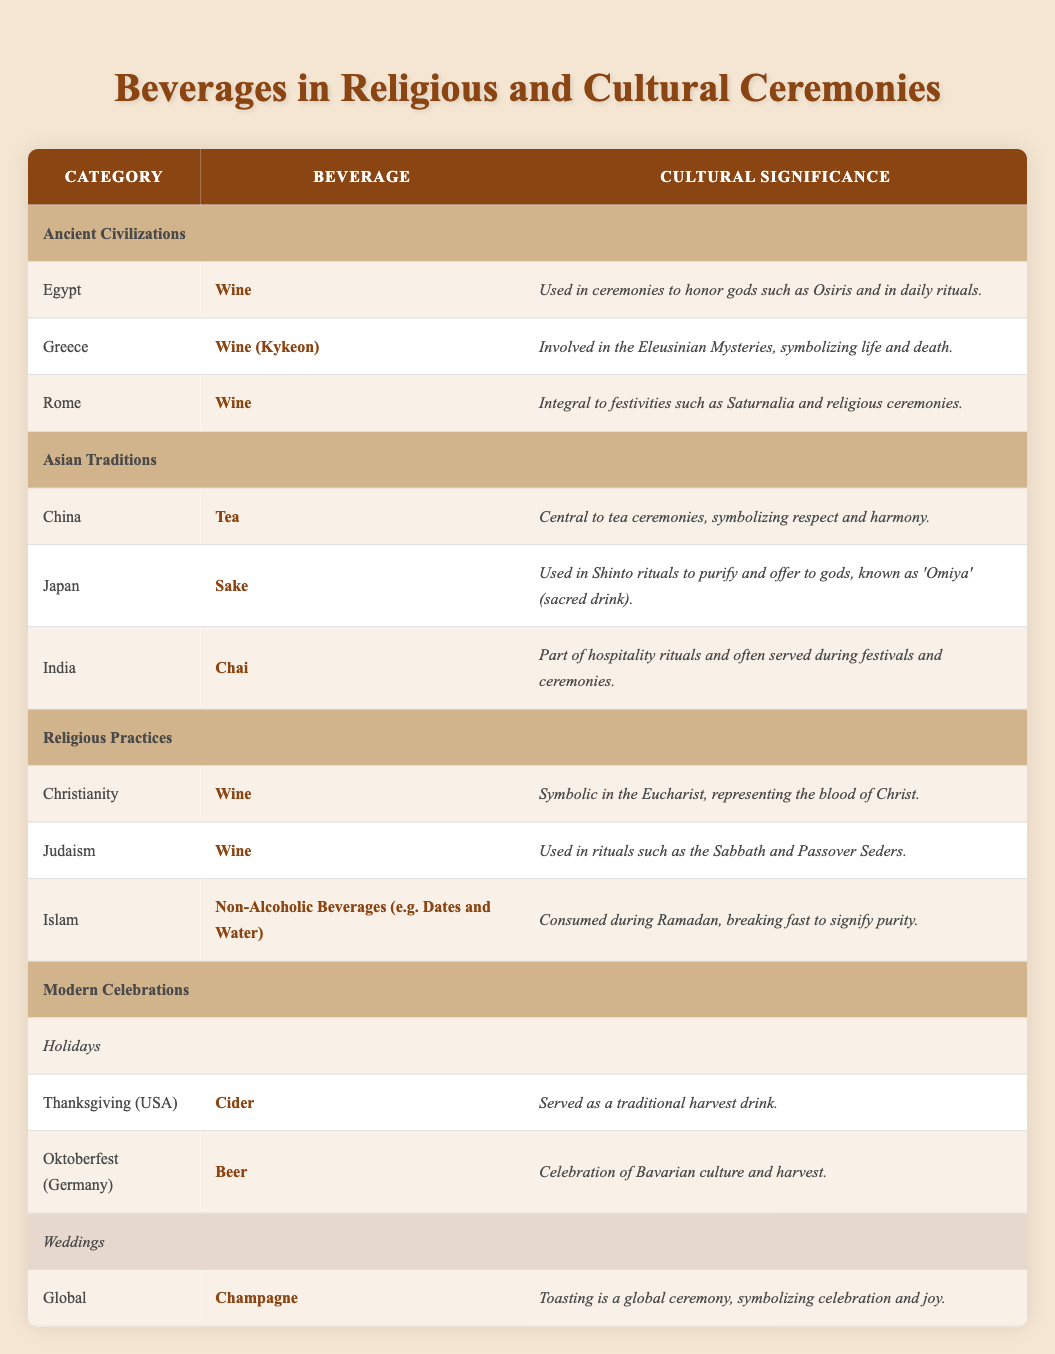What beverage was used in Ancient Egyptian ceremonies? According to the table, the beverage used in Ancient Egyptian ceremonies is wine. This can be found in the 'Ancient Civilizations' section under 'Egypt'.
Answer: Wine Which beverage is central to tea ceremonies in China? The table indicates that tea is the beverage that is central to tea ceremonies in China. This is specifically listed under the 'Asian Traditions' section.
Answer: Tea True or False: Sake is used in Shinto rituals in Japan. The table confirms that sake is used in Shinto rituals as part of its cultural significance, making this statement true. This information is found in the 'Asian Traditions' section under 'Japan'.
Answer: True What are the cultural significances associated with wine in Christianity and Judaism? The cultural significance of wine in Christianity, as listed, is that it is symbolic in the Eucharist, representing the blood of Christ. In Judaism, wine is used in rituals such as the Sabbath and Passover Seders. Both of these details can be found in the 'Religious Practices' section.
Answer: Symbolic in Eucharist (Christianity), used in rituals (Judaism) How many different beverages associated with modern celebrations are listed in the table? The table shows that there are three distinct beverages associated with modern celebrations: cider for Thanksgiving, beer for Oktoberfest, and champagne for weddings. Counting these entries confirms that there are three beverages total.
Answer: 3 What beverage represents a traditional harvest drink in the USA? The table states that cider is served as a traditional harvest drink during Thanksgiving in the USA. This is categorized under the 'Modern Celebrations' section in the 'Holidays' category.
Answer: Cider Which beverage is associated with the celebration of Bavarian culture? According to the table, beer is the beverage associated with the celebration of Bavarian culture during Oktoberfest, which is noted in the 'Modern Celebrations' section under 'Holidays'.
Answer: Beer True or False: All beverages used in religious ceremonies are alcoholic. The table includes a non-alcoholic beverage, specifically non-alcoholic beverages consumed during Ramadan in Islam, which indicates that not all are alcoholic. Thus, the statement is false.
Answer: False What is the common factor among the beverages used in religious practices? In the table, the common factor among the beverages (all wine for Christianity and Judaism and non-alcoholic drinks for Islam) is their symbolic significance in religious rituals. This can be found in the 'Religious Practices' section.
Answer: Symbolic significance in rituals 